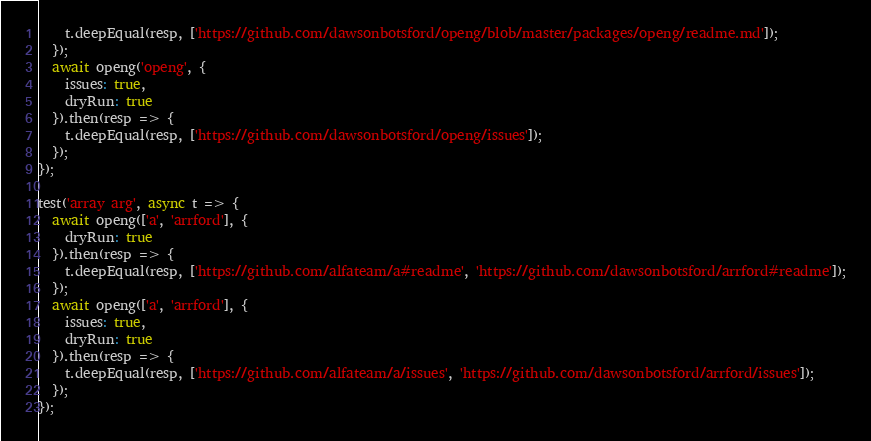Convert code to text. <code><loc_0><loc_0><loc_500><loc_500><_JavaScript_>    t.deepEqual(resp, ['https://github.com/dawsonbotsford/openg/blob/master/packages/openg/readme.md']);
  });
  await openg('openg', {
    issues: true,
    dryRun: true
  }).then(resp => {
    t.deepEqual(resp, ['https://github.com/dawsonbotsford/openg/issues']);
  });
});

test('array arg', async t => {
  await openg(['a', 'arrford'], {
    dryRun: true
  }).then(resp => {
    t.deepEqual(resp, ['https://github.com/alfateam/a#readme', 'https://github.com/dawsonbotsford/arrford#readme']);
  });
  await openg(['a', 'arrford'], {
    issues: true,
    dryRun: true
  }).then(resp => {
    t.deepEqual(resp, ['https://github.com/alfateam/a/issues', 'https://github.com/dawsonbotsford/arrford/issues']);
  });
});
</code> 